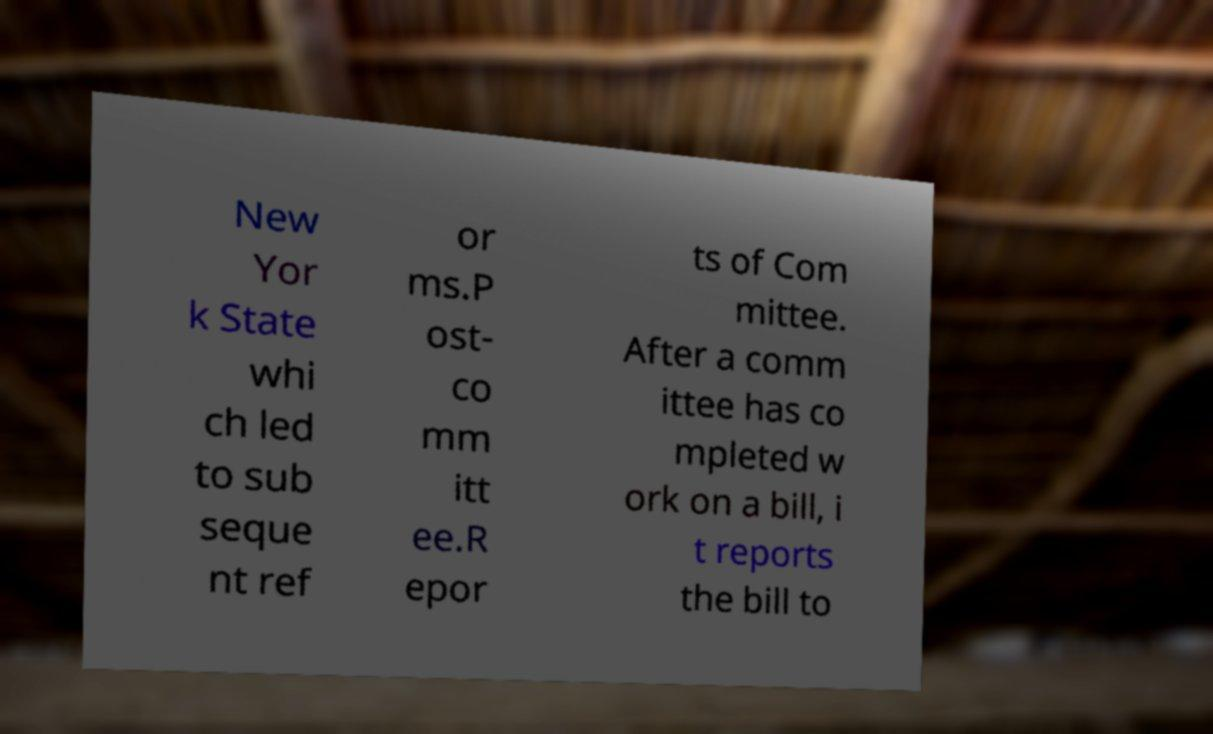Could you extract and type out the text from this image? New Yor k State whi ch led to sub seque nt ref or ms.P ost- co mm itt ee.R epor ts of Com mittee. After a comm ittee has co mpleted w ork on a bill, i t reports the bill to 